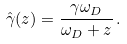<formula> <loc_0><loc_0><loc_500><loc_500>\hat { \gamma } ( z ) = \frac { \gamma \omega _ { D } } { \omega _ { D } + z } \, .</formula> 